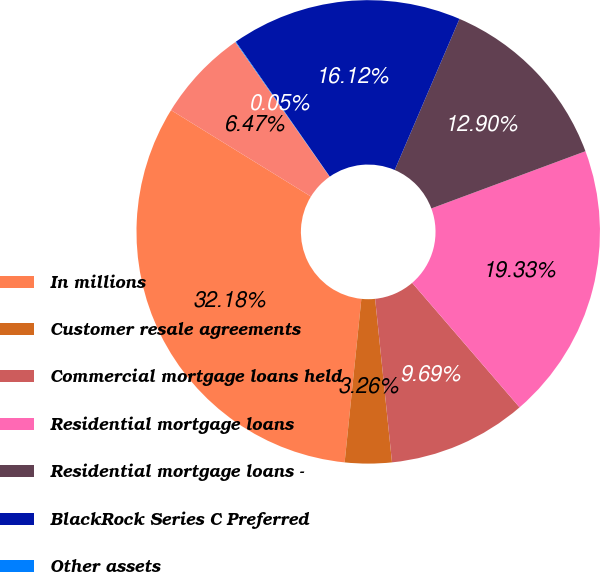Convert chart to OTSL. <chart><loc_0><loc_0><loc_500><loc_500><pie_chart><fcel>In millions<fcel>Customer resale agreements<fcel>Commercial mortgage loans held<fcel>Residential mortgage loans<fcel>Residential mortgage loans -<fcel>BlackRock Series C Preferred<fcel>Other assets<fcel>Other borrowed funds<nl><fcel>32.18%<fcel>3.26%<fcel>9.69%<fcel>19.33%<fcel>12.9%<fcel>16.12%<fcel>0.05%<fcel>6.47%<nl></chart> 